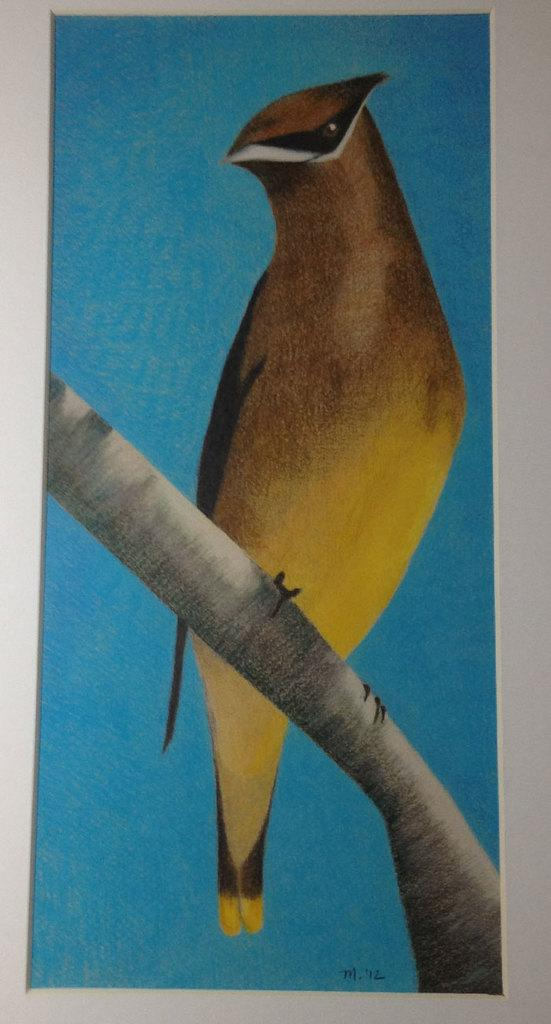What is depicted in the painting in the image? There is a painting of a bird in the image. What type of material is the object that the painting is on? The painting is on a wooden object. What color is the background of the painting? The background of the painting is blue. How many feet are visible in the painting? There are no feet visible in the painting, as it depicts a bird, which does not have feet. 